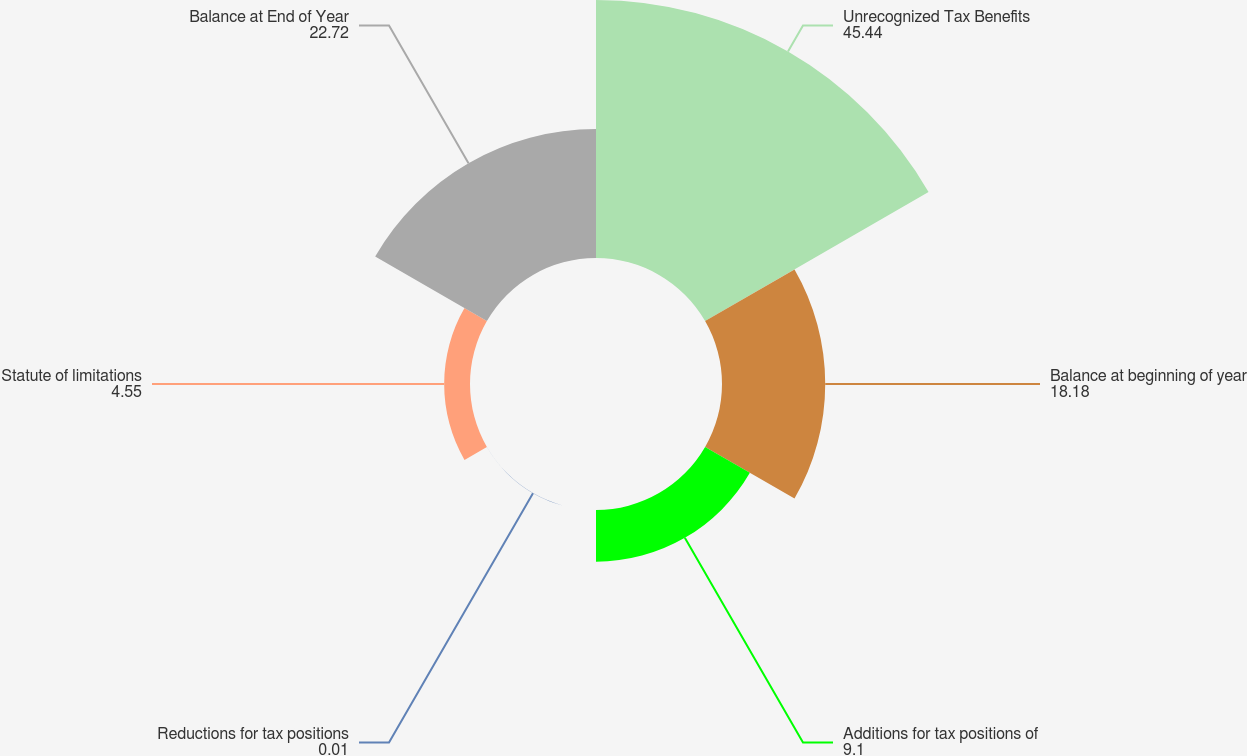<chart> <loc_0><loc_0><loc_500><loc_500><pie_chart><fcel>Unrecognized Tax Benefits<fcel>Balance at beginning of year<fcel>Additions for tax positions of<fcel>Reductions for tax positions<fcel>Statute of limitations<fcel>Balance at End of Year<nl><fcel>45.44%<fcel>18.18%<fcel>9.1%<fcel>0.01%<fcel>4.55%<fcel>22.72%<nl></chart> 